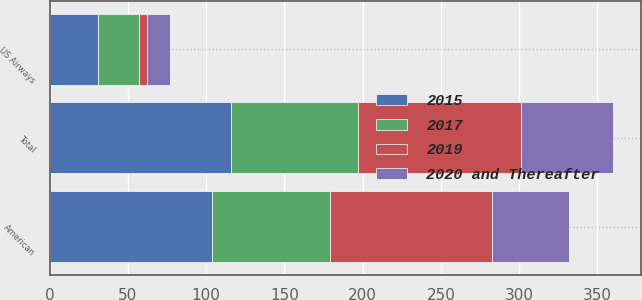Convert chart to OTSL. <chart><loc_0><loc_0><loc_500><loc_500><stacked_bar_chart><ecel><fcel>American<fcel>Total<fcel>US Airways<nl><fcel>2015<fcel>104<fcel>116<fcel>31<nl><fcel>2019<fcel>104<fcel>104<fcel>5<nl><fcel>2017<fcel>75<fcel>81<fcel>26<nl><fcel>2020 and Thereafter<fcel>49<fcel>59<fcel>15<nl></chart> 